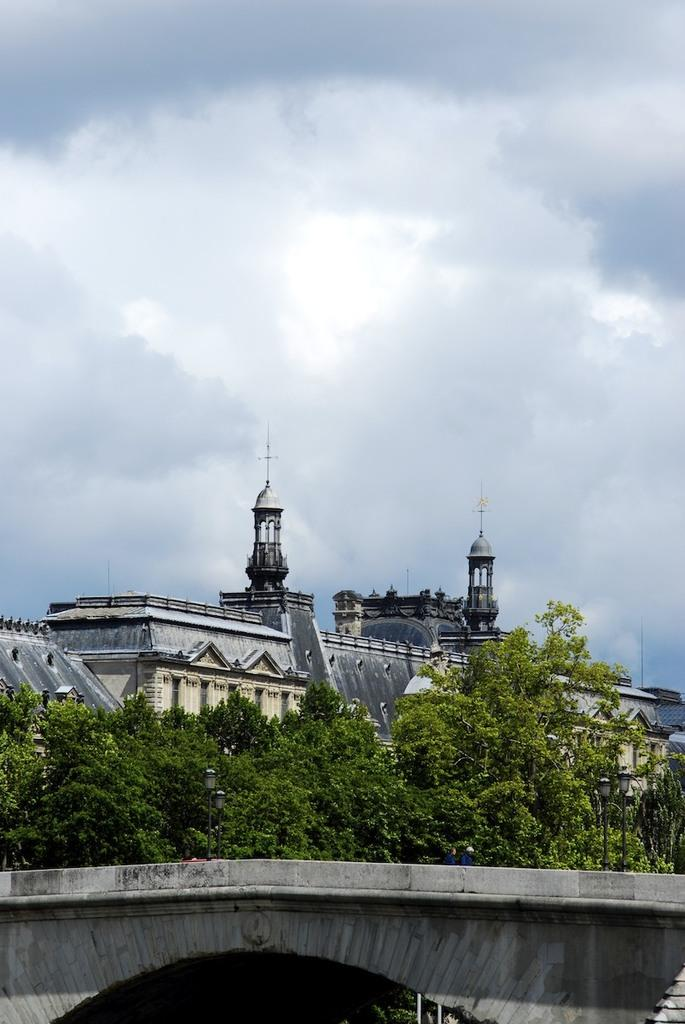What type of vegetation can be seen in the image? There are trees in the image. What is located in the front of the image? There are lights in the front of the image. What can be seen in the background of the image? There are buildings and clouds in the background of the image. What part of the natural environment is visible in the image? The sky is visible in the background of the image. What type of flowers can be seen growing near the lights in the image? There are no flowers visible in the image; the focus is on the trees, lights, buildings, clouds, and sky. 